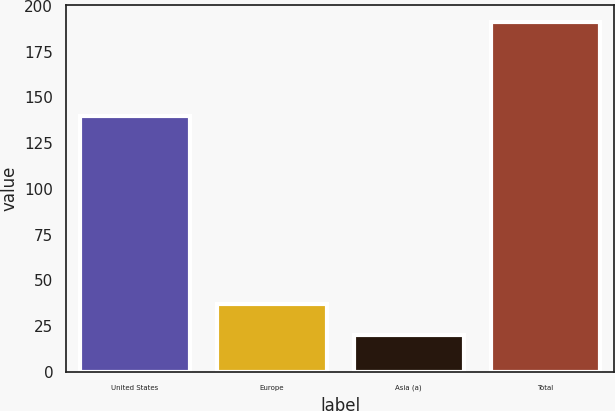Convert chart to OTSL. <chart><loc_0><loc_0><loc_500><loc_500><bar_chart><fcel>United States<fcel>Europe<fcel>Asia (a)<fcel>Total<nl><fcel>140<fcel>37.1<fcel>20<fcel>191<nl></chart> 